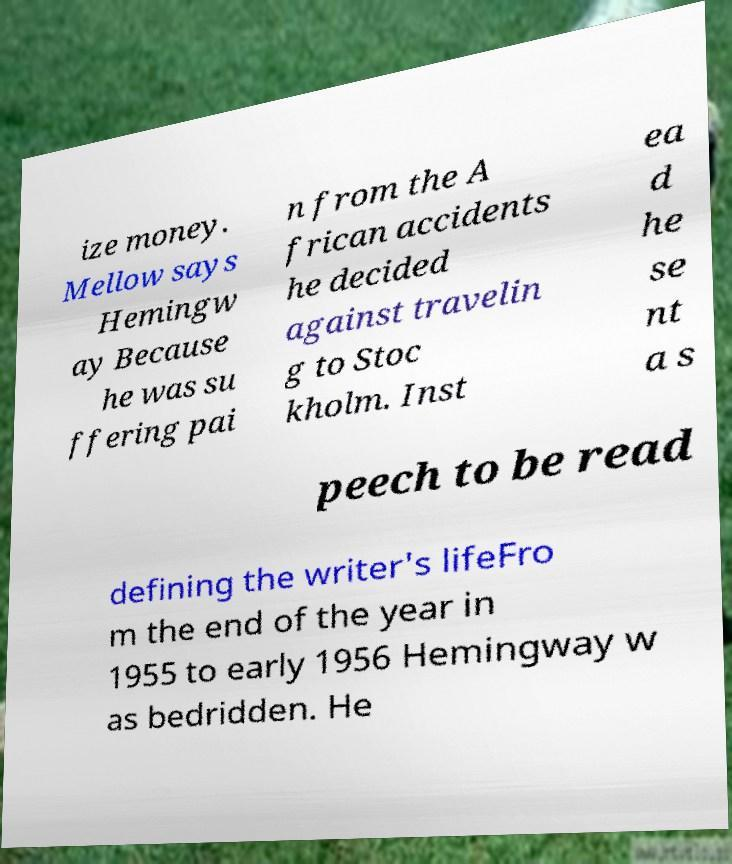Could you extract and type out the text from this image? ize money. Mellow says Hemingw ay Because he was su ffering pai n from the A frican accidents he decided against travelin g to Stoc kholm. Inst ea d he se nt a s peech to be read defining the writer's lifeFro m the end of the year in 1955 to early 1956 Hemingway w as bedridden. He 